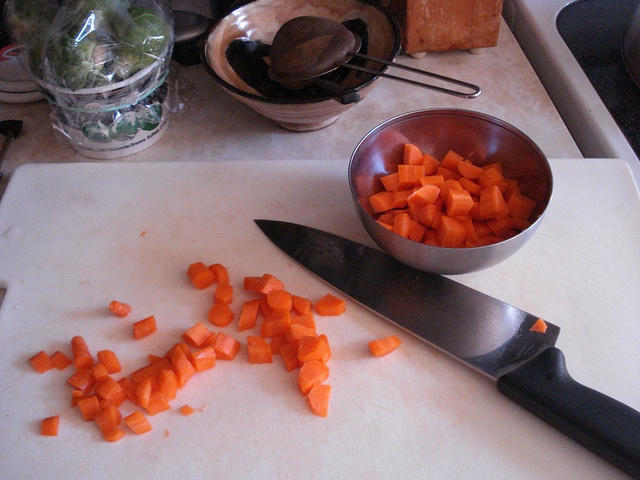Describe the objects in this image and their specific colors. I can see knife in black, gray, and darkgray tones, bowl in black, maroon, brown, gray, and red tones, bowl in black, maroon, brown, and gray tones, carrot in black, brown, maroon, and red tones, and carrot in black, brown, red, and salmon tones in this image. 